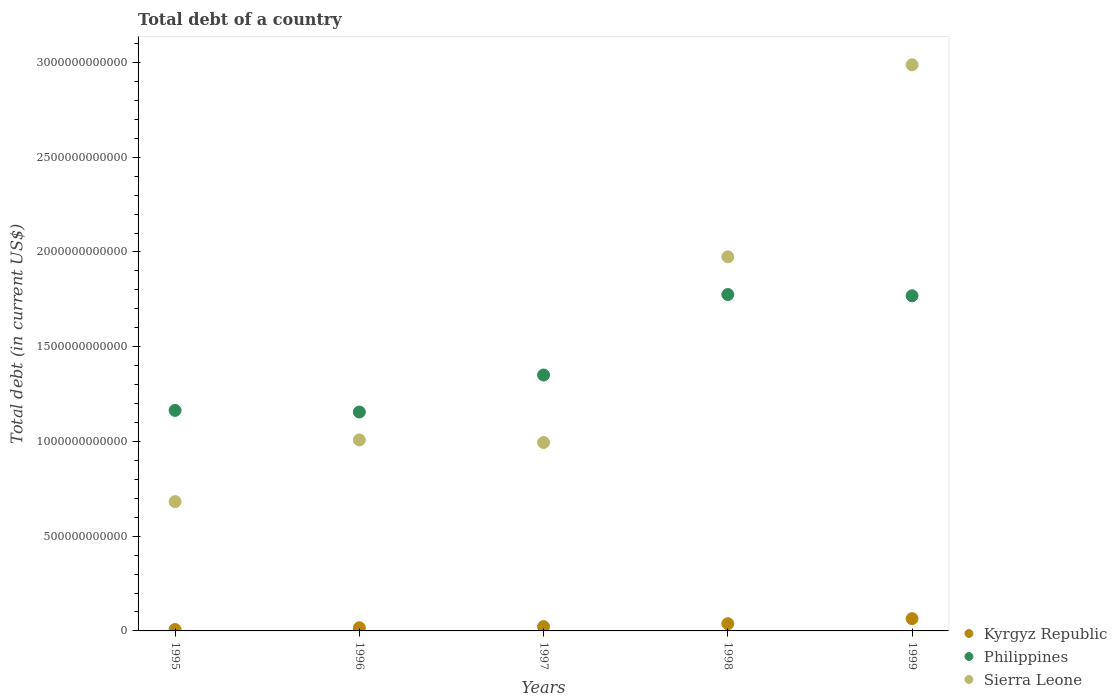What is the debt in Sierra Leone in 1995?
Keep it short and to the point. 6.82e+11. Across all years, what is the maximum debt in Philippines?
Your answer should be very brief. 1.78e+12. Across all years, what is the minimum debt in Philippines?
Keep it short and to the point. 1.16e+12. In which year was the debt in Philippines maximum?
Give a very brief answer. 1998. What is the total debt in Sierra Leone in the graph?
Give a very brief answer. 7.65e+12. What is the difference between the debt in Kyrgyz Republic in 1996 and that in 1997?
Provide a short and direct response. -5.96e+09. What is the difference between the debt in Philippines in 1998 and the debt in Kyrgyz Republic in 1997?
Your answer should be compact. 1.75e+12. What is the average debt in Kyrgyz Republic per year?
Provide a short and direct response. 2.99e+1. In the year 1996, what is the difference between the debt in Sierra Leone and debt in Kyrgyz Republic?
Your response must be concise. 9.91e+11. What is the ratio of the debt in Sierra Leone in 1997 to that in 1999?
Provide a succinct answer. 0.33. What is the difference between the highest and the second highest debt in Philippines?
Provide a succinct answer. 6.66e+09. What is the difference between the highest and the lowest debt in Sierra Leone?
Provide a short and direct response. 2.31e+12. Is it the case that in every year, the sum of the debt in Philippines and debt in Kyrgyz Republic  is greater than the debt in Sierra Leone?
Your answer should be very brief. No. Is the debt in Sierra Leone strictly greater than the debt in Philippines over the years?
Provide a short and direct response. No. Is the debt in Kyrgyz Republic strictly less than the debt in Philippines over the years?
Make the answer very short. Yes. What is the difference between two consecutive major ticks on the Y-axis?
Ensure brevity in your answer.  5.00e+11. Does the graph contain grids?
Your answer should be very brief. No. Where does the legend appear in the graph?
Offer a very short reply. Bottom right. How are the legend labels stacked?
Provide a short and direct response. Vertical. What is the title of the graph?
Your answer should be very brief. Total debt of a country. What is the label or title of the Y-axis?
Make the answer very short. Total debt (in current US$). What is the Total debt (in current US$) of Kyrgyz Republic in 1995?
Your answer should be very brief. 7.36e+09. What is the Total debt (in current US$) of Philippines in 1995?
Your response must be concise. 1.16e+12. What is the Total debt (in current US$) of Sierra Leone in 1995?
Your response must be concise. 6.82e+11. What is the Total debt (in current US$) in Kyrgyz Republic in 1996?
Your answer should be very brief. 1.67e+1. What is the Total debt (in current US$) in Philippines in 1996?
Your response must be concise. 1.16e+12. What is the Total debt (in current US$) of Sierra Leone in 1996?
Give a very brief answer. 1.01e+12. What is the Total debt (in current US$) in Kyrgyz Republic in 1997?
Your response must be concise. 2.27e+1. What is the Total debt (in current US$) in Philippines in 1997?
Keep it short and to the point. 1.35e+12. What is the Total debt (in current US$) of Sierra Leone in 1997?
Ensure brevity in your answer.  9.94e+11. What is the Total debt (in current US$) of Kyrgyz Republic in 1998?
Your answer should be compact. 3.80e+1. What is the Total debt (in current US$) in Philippines in 1998?
Your answer should be very brief. 1.78e+12. What is the Total debt (in current US$) in Sierra Leone in 1998?
Offer a terse response. 1.97e+12. What is the Total debt (in current US$) in Kyrgyz Republic in 1999?
Your answer should be very brief. 6.47e+1. What is the Total debt (in current US$) in Philippines in 1999?
Give a very brief answer. 1.77e+12. What is the Total debt (in current US$) in Sierra Leone in 1999?
Offer a very short reply. 2.99e+12. Across all years, what is the maximum Total debt (in current US$) in Kyrgyz Republic?
Your answer should be very brief. 6.47e+1. Across all years, what is the maximum Total debt (in current US$) in Philippines?
Provide a succinct answer. 1.78e+12. Across all years, what is the maximum Total debt (in current US$) of Sierra Leone?
Provide a succinct answer. 2.99e+12. Across all years, what is the minimum Total debt (in current US$) of Kyrgyz Republic?
Provide a short and direct response. 7.36e+09. Across all years, what is the minimum Total debt (in current US$) in Philippines?
Provide a short and direct response. 1.16e+12. Across all years, what is the minimum Total debt (in current US$) in Sierra Leone?
Provide a short and direct response. 6.82e+11. What is the total Total debt (in current US$) in Kyrgyz Republic in the graph?
Keep it short and to the point. 1.49e+11. What is the total Total debt (in current US$) in Philippines in the graph?
Your response must be concise. 7.21e+12. What is the total Total debt (in current US$) of Sierra Leone in the graph?
Your answer should be very brief. 7.65e+12. What is the difference between the Total debt (in current US$) in Kyrgyz Republic in 1995 and that in 1996?
Keep it short and to the point. -9.35e+09. What is the difference between the Total debt (in current US$) of Philippines in 1995 and that in 1996?
Offer a terse response. 8.61e+09. What is the difference between the Total debt (in current US$) of Sierra Leone in 1995 and that in 1996?
Provide a succinct answer. -3.26e+11. What is the difference between the Total debt (in current US$) of Kyrgyz Republic in 1995 and that in 1997?
Offer a very short reply. -1.53e+1. What is the difference between the Total debt (in current US$) in Philippines in 1995 and that in 1997?
Provide a short and direct response. -1.87e+11. What is the difference between the Total debt (in current US$) in Sierra Leone in 1995 and that in 1997?
Your answer should be compact. -3.12e+11. What is the difference between the Total debt (in current US$) of Kyrgyz Republic in 1995 and that in 1998?
Give a very brief answer. -3.07e+1. What is the difference between the Total debt (in current US$) of Philippines in 1995 and that in 1998?
Your response must be concise. -6.12e+11. What is the difference between the Total debt (in current US$) in Sierra Leone in 1995 and that in 1998?
Ensure brevity in your answer.  -1.29e+12. What is the difference between the Total debt (in current US$) of Kyrgyz Republic in 1995 and that in 1999?
Your response must be concise. -5.73e+1. What is the difference between the Total debt (in current US$) in Philippines in 1995 and that in 1999?
Offer a terse response. -6.05e+11. What is the difference between the Total debt (in current US$) in Sierra Leone in 1995 and that in 1999?
Provide a succinct answer. -2.31e+12. What is the difference between the Total debt (in current US$) in Kyrgyz Republic in 1996 and that in 1997?
Ensure brevity in your answer.  -5.96e+09. What is the difference between the Total debt (in current US$) in Philippines in 1996 and that in 1997?
Offer a terse response. -1.95e+11. What is the difference between the Total debt (in current US$) of Sierra Leone in 1996 and that in 1997?
Your answer should be compact. 1.37e+1. What is the difference between the Total debt (in current US$) in Kyrgyz Republic in 1996 and that in 1998?
Your answer should be compact. -2.13e+1. What is the difference between the Total debt (in current US$) in Philippines in 1996 and that in 1998?
Your answer should be very brief. -6.20e+11. What is the difference between the Total debt (in current US$) in Sierra Leone in 1996 and that in 1998?
Offer a very short reply. -9.66e+11. What is the difference between the Total debt (in current US$) of Kyrgyz Republic in 1996 and that in 1999?
Give a very brief answer. -4.80e+1. What is the difference between the Total debt (in current US$) of Philippines in 1996 and that in 1999?
Offer a very short reply. -6.13e+11. What is the difference between the Total debt (in current US$) in Sierra Leone in 1996 and that in 1999?
Your response must be concise. -1.98e+12. What is the difference between the Total debt (in current US$) in Kyrgyz Republic in 1997 and that in 1998?
Offer a very short reply. -1.53e+1. What is the difference between the Total debt (in current US$) in Philippines in 1997 and that in 1998?
Make the answer very short. -4.25e+11. What is the difference between the Total debt (in current US$) of Sierra Leone in 1997 and that in 1998?
Ensure brevity in your answer.  -9.80e+11. What is the difference between the Total debt (in current US$) of Kyrgyz Republic in 1997 and that in 1999?
Provide a succinct answer. -4.20e+1. What is the difference between the Total debt (in current US$) in Philippines in 1997 and that in 1999?
Make the answer very short. -4.18e+11. What is the difference between the Total debt (in current US$) of Sierra Leone in 1997 and that in 1999?
Offer a terse response. -1.99e+12. What is the difference between the Total debt (in current US$) in Kyrgyz Republic in 1998 and that in 1999?
Your answer should be very brief. -2.67e+1. What is the difference between the Total debt (in current US$) of Philippines in 1998 and that in 1999?
Your response must be concise. 6.66e+09. What is the difference between the Total debt (in current US$) in Sierra Leone in 1998 and that in 1999?
Offer a terse response. -1.01e+12. What is the difference between the Total debt (in current US$) in Kyrgyz Republic in 1995 and the Total debt (in current US$) in Philippines in 1996?
Provide a succinct answer. -1.15e+12. What is the difference between the Total debt (in current US$) of Kyrgyz Republic in 1995 and the Total debt (in current US$) of Sierra Leone in 1996?
Keep it short and to the point. -1.00e+12. What is the difference between the Total debt (in current US$) of Philippines in 1995 and the Total debt (in current US$) of Sierra Leone in 1996?
Provide a short and direct response. 1.56e+11. What is the difference between the Total debt (in current US$) of Kyrgyz Republic in 1995 and the Total debt (in current US$) of Philippines in 1997?
Offer a very short reply. -1.34e+12. What is the difference between the Total debt (in current US$) in Kyrgyz Republic in 1995 and the Total debt (in current US$) in Sierra Leone in 1997?
Your answer should be compact. -9.87e+11. What is the difference between the Total debt (in current US$) in Philippines in 1995 and the Total debt (in current US$) in Sierra Leone in 1997?
Offer a terse response. 1.70e+11. What is the difference between the Total debt (in current US$) in Kyrgyz Republic in 1995 and the Total debt (in current US$) in Philippines in 1998?
Provide a succinct answer. -1.77e+12. What is the difference between the Total debt (in current US$) in Kyrgyz Republic in 1995 and the Total debt (in current US$) in Sierra Leone in 1998?
Provide a succinct answer. -1.97e+12. What is the difference between the Total debt (in current US$) of Philippines in 1995 and the Total debt (in current US$) of Sierra Leone in 1998?
Make the answer very short. -8.10e+11. What is the difference between the Total debt (in current US$) of Kyrgyz Republic in 1995 and the Total debt (in current US$) of Philippines in 1999?
Give a very brief answer. -1.76e+12. What is the difference between the Total debt (in current US$) of Kyrgyz Republic in 1995 and the Total debt (in current US$) of Sierra Leone in 1999?
Make the answer very short. -2.98e+12. What is the difference between the Total debt (in current US$) in Philippines in 1995 and the Total debt (in current US$) in Sierra Leone in 1999?
Make the answer very short. -1.82e+12. What is the difference between the Total debt (in current US$) in Kyrgyz Republic in 1996 and the Total debt (in current US$) in Philippines in 1997?
Offer a very short reply. -1.33e+12. What is the difference between the Total debt (in current US$) of Kyrgyz Republic in 1996 and the Total debt (in current US$) of Sierra Leone in 1997?
Your answer should be very brief. -9.78e+11. What is the difference between the Total debt (in current US$) of Philippines in 1996 and the Total debt (in current US$) of Sierra Leone in 1997?
Give a very brief answer. 1.61e+11. What is the difference between the Total debt (in current US$) of Kyrgyz Republic in 1996 and the Total debt (in current US$) of Philippines in 1998?
Offer a very short reply. -1.76e+12. What is the difference between the Total debt (in current US$) of Kyrgyz Republic in 1996 and the Total debt (in current US$) of Sierra Leone in 1998?
Provide a short and direct response. -1.96e+12. What is the difference between the Total debt (in current US$) in Philippines in 1996 and the Total debt (in current US$) in Sierra Leone in 1998?
Give a very brief answer. -8.19e+11. What is the difference between the Total debt (in current US$) in Kyrgyz Republic in 1996 and the Total debt (in current US$) in Philippines in 1999?
Keep it short and to the point. -1.75e+12. What is the difference between the Total debt (in current US$) in Kyrgyz Republic in 1996 and the Total debt (in current US$) in Sierra Leone in 1999?
Offer a very short reply. -2.97e+12. What is the difference between the Total debt (in current US$) in Philippines in 1996 and the Total debt (in current US$) in Sierra Leone in 1999?
Your answer should be very brief. -1.83e+12. What is the difference between the Total debt (in current US$) in Kyrgyz Republic in 1997 and the Total debt (in current US$) in Philippines in 1998?
Make the answer very short. -1.75e+12. What is the difference between the Total debt (in current US$) of Kyrgyz Republic in 1997 and the Total debt (in current US$) of Sierra Leone in 1998?
Your answer should be compact. -1.95e+12. What is the difference between the Total debt (in current US$) of Philippines in 1997 and the Total debt (in current US$) of Sierra Leone in 1998?
Keep it short and to the point. -6.24e+11. What is the difference between the Total debt (in current US$) in Kyrgyz Republic in 1997 and the Total debt (in current US$) in Philippines in 1999?
Offer a very short reply. -1.75e+12. What is the difference between the Total debt (in current US$) in Kyrgyz Republic in 1997 and the Total debt (in current US$) in Sierra Leone in 1999?
Your response must be concise. -2.96e+12. What is the difference between the Total debt (in current US$) of Philippines in 1997 and the Total debt (in current US$) of Sierra Leone in 1999?
Offer a terse response. -1.64e+12. What is the difference between the Total debt (in current US$) in Kyrgyz Republic in 1998 and the Total debt (in current US$) in Philippines in 1999?
Your answer should be very brief. -1.73e+12. What is the difference between the Total debt (in current US$) in Kyrgyz Republic in 1998 and the Total debt (in current US$) in Sierra Leone in 1999?
Offer a terse response. -2.95e+12. What is the difference between the Total debt (in current US$) in Philippines in 1998 and the Total debt (in current US$) in Sierra Leone in 1999?
Keep it short and to the point. -1.21e+12. What is the average Total debt (in current US$) of Kyrgyz Republic per year?
Keep it short and to the point. 2.99e+1. What is the average Total debt (in current US$) of Philippines per year?
Ensure brevity in your answer.  1.44e+12. What is the average Total debt (in current US$) in Sierra Leone per year?
Provide a short and direct response. 1.53e+12. In the year 1995, what is the difference between the Total debt (in current US$) of Kyrgyz Republic and Total debt (in current US$) of Philippines?
Offer a very short reply. -1.16e+12. In the year 1995, what is the difference between the Total debt (in current US$) of Kyrgyz Republic and Total debt (in current US$) of Sierra Leone?
Provide a succinct answer. -6.75e+11. In the year 1995, what is the difference between the Total debt (in current US$) of Philippines and Total debt (in current US$) of Sierra Leone?
Your answer should be very brief. 4.82e+11. In the year 1996, what is the difference between the Total debt (in current US$) in Kyrgyz Republic and Total debt (in current US$) in Philippines?
Your answer should be very brief. -1.14e+12. In the year 1996, what is the difference between the Total debt (in current US$) of Kyrgyz Republic and Total debt (in current US$) of Sierra Leone?
Offer a terse response. -9.91e+11. In the year 1996, what is the difference between the Total debt (in current US$) in Philippines and Total debt (in current US$) in Sierra Leone?
Offer a very short reply. 1.47e+11. In the year 1997, what is the difference between the Total debt (in current US$) of Kyrgyz Republic and Total debt (in current US$) of Philippines?
Your answer should be very brief. -1.33e+12. In the year 1997, what is the difference between the Total debt (in current US$) in Kyrgyz Republic and Total debt (in current US$) in Sierra Leone?
Offer a terse response. -9.72e+11. In the year 1997, what is the difference between the Total debt (in current US$) of Philippines and Total debt (in current US$) of Sierra Leone?
Make the answer very short. 3.56e+11. In the year 1998, what is the difference between the Total debt (in current US$) of Kyrgyz Republic and Total debt (in current US$) of Philippines?
Offer a very short reply. -1.74e+12. In the year 1998, what is the difference between the Total debt (in current US$) of Kyrgyz Republic and Total debt (in current US$) of Sierra Leone?
Give a very brief answer. -1.94e+12. In the year 1998, what is the difference between the Total debt (in current US$) of Philippines and Total debt (in current US$) of Sierra Leone?
Keep it short and to the point. -1.99e+11. In the year 1999, what is the difference between the Total debt (in current US$) in Kyrgyz Republic and Total debt (in current US$) in Philippines?
Offer a terse response. -1.70e+12. In the year 1999, what is the difference between the Total debt (in current US$) of Kyrgyz Republic and Total debt (in current US$) of Sierra Leone?
Offer a very short reply. -2.92e+12. In the year 1999, what is the difference between the Total debt (in current US$) of Philippines and Total debt (in current US$) of Sierra Leone?
Offer a very short reply. -1.22e+12. What is the ratio of the Total debt (in current US$) in Kyrgyz Republic in 1995 to that in 1996?
Ensure brevity in your answer.  0.44. What is the ratio of the Total debt (in current US$) of Philippines in 1995 to that in 1996?
Your answer should be compact. 1.01. What is the ratio of the Total debt (in current US$) of Sierra Leone in 1995 to that in 1996?
Make the answer very short. 0.68. What is the ratio of the Total debt (in current US$) of Kyrgyz Republic in 1995 to that in 1997?
Provide a short and direct response. 0.32. What is the ratio of the Total debt (in current US$) in Philippines in 1995 to that in 1997?
Ensure brevity in your answer.  0.86. What is the ratio of the Total debt (in current US$) of Sierra Leone in 1995 to that in 1997?
Give a very brief answer. 0.69. What is the ratio of the Total debt (in current US$) of Kyrgyz Republic in 1995 to that in 1998?
Give a very brief answer. 0.19. What is the ratio of the Total debt (in current US$) of Philippines in 1995 to that in 1998?
Offer a terse response. 0.66. What is the ratio of the Total debt (in current US$) in Sierra Leone in 1995 to that in 1998?
Your answer should be compact. 0.35. What is the ratio of the Total debt (in current US$) in Kyrgyz Republic in 1995 to that in 1999?
Provide a short and direct response. 0.11. What is the ratio of the Total debt (in current US$) of Philippines in 1995 to that in 1999?
Your answer should be very brief. 0.66. What is the ratio of the Total debt (in current US$) in Sierra Leone in 1995 to that in 1999?
Provide a succinct answer. 0.23. What is the ratio of the Total debt (in current US$) of Kyrgyz Republic in 1996 to that in 1997?
Make the answer very short. 0.74. What is the ratio of the Total debt (in current US$) of Philippines in 1996 to that in 1997?
Offer a terse response. 0.86. What is the ratio of the Total debt (in current US$) of Sierra Leone in 1996 to that in 1997?
Make the answer very short. 1.01. What is the ratio of the Total debt (in current US$) of Kyrgyz Republic in 1996 to that in 1998?
Keep it short and to the point. 0.44. What is the ratio of the Total debt (in current US$) in Philippines in 1996 to that in 1998?
Give a very brief answer. 0.65. What is the ratio of the Total debt (in current US$) in Sierra Leone in 1996 to that in 1998?
Offer a terse response. 0.51. What is the ratio of the Total debt (in current US$) of Kyrgyz Republic in 1996 to that in 1999?
Give a very brief answer. 0.26. What is the ratio of the Total debt (in current US$) in Philippines in 1996 to that in 1999?
Provide a short and direct response. 0.65. What is the ratio of the Total debt (in current US$) of Sierra Leone in 1996 to that in 1999?
Ensure brevity in your answer.  0.34. What is the ratio of the Total debt (in current US$) of Kyrgyz Republic in 1997 to that in 1998?
Offer a terse response. 0.6. What is the ratio of the Total debt (in current US$) in Philippines in 1997 to that in 1998?
Provide a succinct answer. 0.76. What is the ratio of the Total debt (in current US$) of Sierra Leone in 1997 to that in 1998?
Keep it short and to the point. 0.5. What is the ratio of the Total debt (in current US$) in Kyrgyz Republic in 1997 to that in 1999?
Give a very brief answer. 0.35. What is the ratio of the Total debt (in current US$) of Philippines in 1997 to that in 1999?
Offer a terse response. 0.76. What is the ratio of the Total debt (in current US$) in Sierra Leone in 1997 to that in 1999?
Give a very brief answer. 0.33. What is the ratio of the Total debt (in current US$) of Kyrgyz Republic in 1998 to that in 1999?
Provide a short and direct response. 0.59. What is the ratio of the Total debt (in current US$) in Philippines in 1998 to that in 1999?
Provide a short and direct response. 1. What is the ratio of the Total debt (in current US$) of Sierra Leone in 1998 to that in 1999?
Ensure brevity in your answer.  0.66. What is the difference between the highest and the second highest Total debt (in current US$) in Kyrgyz Republic?
Keep it short and to the point. 2.67e+1. What is the difference between the highest and the second highest Total debt (in current US$) of Philippines?
Give a very brief answer. 6.66e+09. What is the difference between the highest and the second highest Total debt (in current US$) in Sierra Leone?
Give a very brief answer. 1.01e+12. What is the difference between the highest and the lowest Total debt (in current US$) in Kyrgyz Republic?
Your answer should be compact. 5.73e+1. What is the difference between the highest and the lowest Total debt (in current US$) in Philippines?
Your answer should be very brief. 6.20e+11. What is the difference between the highest and the lowest Total debt (in current US$) of Sierra Leone?
Your answer should be compact. 2.31e+12. 